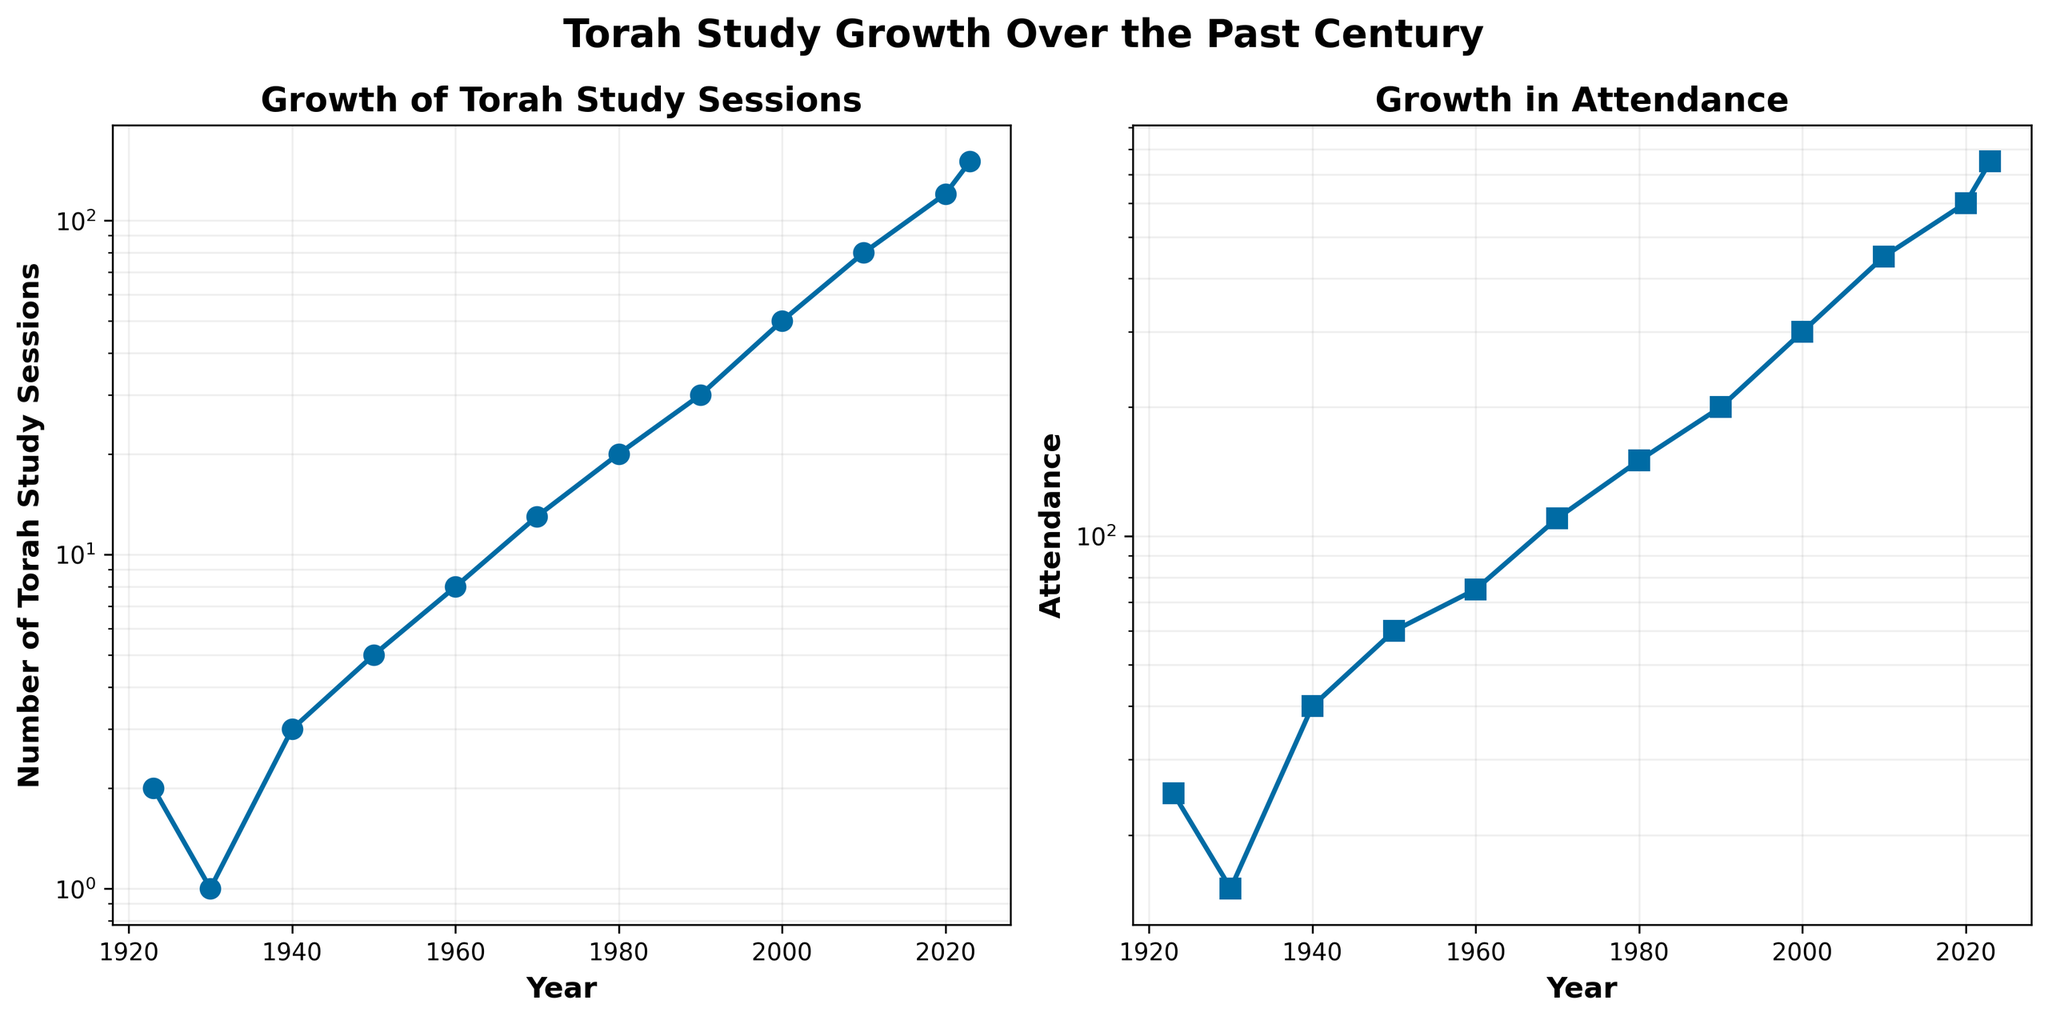Which subplot displays the growth of Torah study sessions? The subplot on the left titled "Growth of Torah Study Sessions" shows the number of Torah study sessions over the years. This can be identified by its title and the corresponding y-axis label.
Answer: The one on the left What is the title of the second subplot? The second subplot, which is the one on the right, is titled "Growth in Attendance." This information is clearly mentioned above the subplot.
Answer: Growth in Attendance How many Torah study sessions were held in 1970? By looking at the left subplot and tracing the data point corresponding to the year 1970 on the x-axis, we can find the y-axis value, which is the number of sessions. The data point shows 13 Torah study sessions in 1970.
Answer: 13 When did attendance first exceed 200? By observing the second subplot, and checking the attendance values on the y-axis, it can be seen that attendance first exceeds 200 in the year 2000. The data point for 2000 shows an attendance of 300.
Answer: 2000 What is the average number of Torah study sessions per decade from 1923 to 2023? First, sum the number of sessions from 1923 to 2023 (2+1+3+5+8+13+20+30+50+80+120+150 = 482). There are 11 decades in this period (1923-2023). Divide the total number of sessions by the number of decades (482/11 ≈ 43.82).
Answer: ≈ 43.82 Which year had a higher attendance, 2010 or 1990? Refer to the second subplot and compare the attendance for the years 2010 and 1990. The attendance in 2010 is 450, while in 1990 it is 200.
Answer: 2010 By what factor did the attendance increase from 1960 to 2023? Attendance in 1960 was 75, and in 2023 it is 750. Calculate the factor by dividing the attendance in 2023 by the attendance in 1960 (750/75 = 10). Attendance increased by a factor of 10.
Answer: 10 What is the general trend in both Torah study sessions and their attendance over the years? The general trend in both subplots shows exponential growth over the years, which is evidenced by the steep increase in both the number of Torah study sessions and attendance.
Answer: Exponential growth Are the changes in Torah study sessions and attendance proportional over the years? By analyzing the data points and the steepness of the curves in both subplots, one can observe that both the number of Torah study sessions and attendance increase exponentially, indicating a proportional relationship.
Answer: Yes 